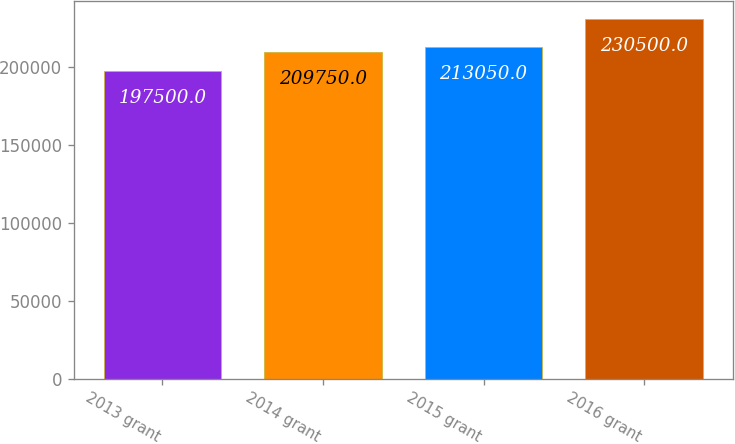Convert chart. <chart><loc_0><loc_0><loc_500><loc_500><bar_chart><fcel>2013 grant<fcel>2014 grant<fcel>2015 grant<fcel>2016 grant<nl><fcel>197500<fcel>209750<fcel>213050<fcel>230500<nl></chart> 